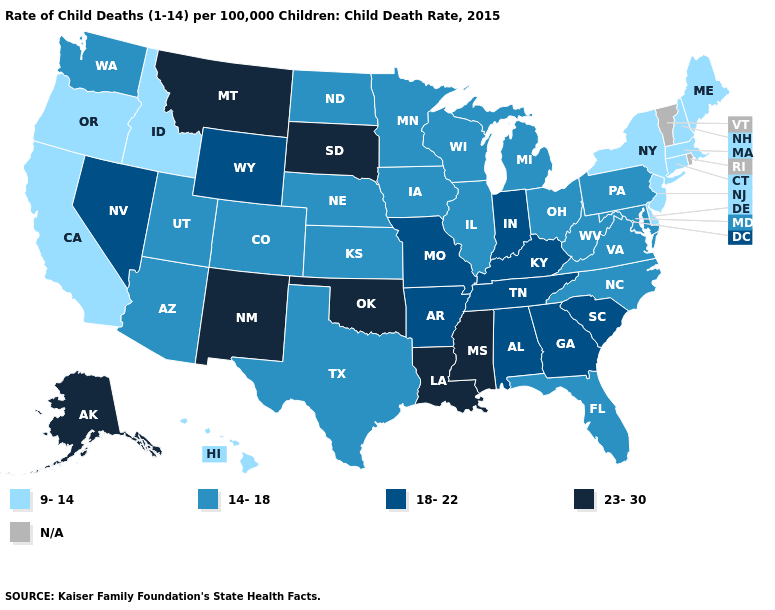Name the states that have a value in the range N/A?
Quick response, please. Rhode Island, Vermont. Name the states that have a value in the range 14-18?
Concise answer only. Arizona, Colorado, Florida, Illinois, Iowa, Kansas, Maryland, Michigan, Minnesota, Nebraska, North Carolina, North Dakota, Ohio, Pennsylvania, Texas, Utah, Virginia, Washington, West Virginia, Wisconsin. What is the highest value in states that border Minnesota?
Short answer required. 23-30. What is the value of New Mexico?
Short answer required. 23-30. Which states have the highest value in the USA?
Short answer required. Alaska, Louisiana, Mississippi, Montana, New Mexico, Oklahoma, South Dakota. What is the highest value in states that border North Carolina?
Keep it brief. 18-22. What is the highest value in the USA?
Write a very short answer. 23-30. Does Oregon have the lowest value in the USA?
Give a very brief answer. Yes. Does South Dakota have the lowest value in the MidWest?
Write a very short answer. No. What is the value of North Carolina?
Short answer required. 14-18. Does South Dakota have the highest value in the USA?
Short answer required. Yes. Which states hav the highest value in the MidWest?
Give a very brief answer. South Dakota. What is the lowest value in states that border Missouri?
Be succinct. 14-18. 